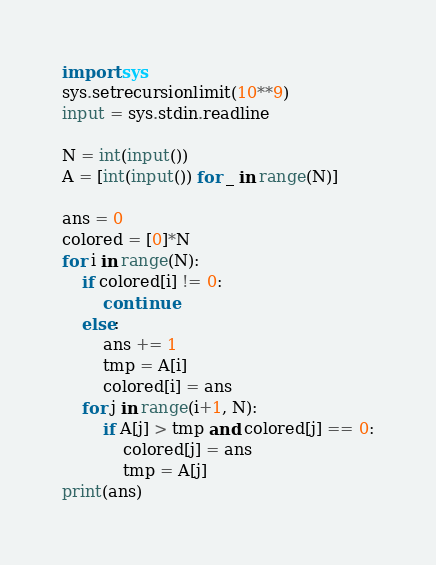Convert code to text. <code><loc_0><loc_0><loc_500><loc_500><_Python_>import sys
sys.setrecursionlimit(10**9)
input = sys.stdin.readline

N = int(input())
A = [int(input()) for _ in range(N)]

ans = 0
colored = [0]*N
for i in range(N):
    if colored[i] != 0:
        continue
    else:
        ans += 1
        tmp = A[i]
        colored[i] = ans
    for j in range(i+1, N):
        if A[j] > tmp and colored[j] == 0:
            colored[j] = ans
            tmp = A[j]
print(ans)
</code> 